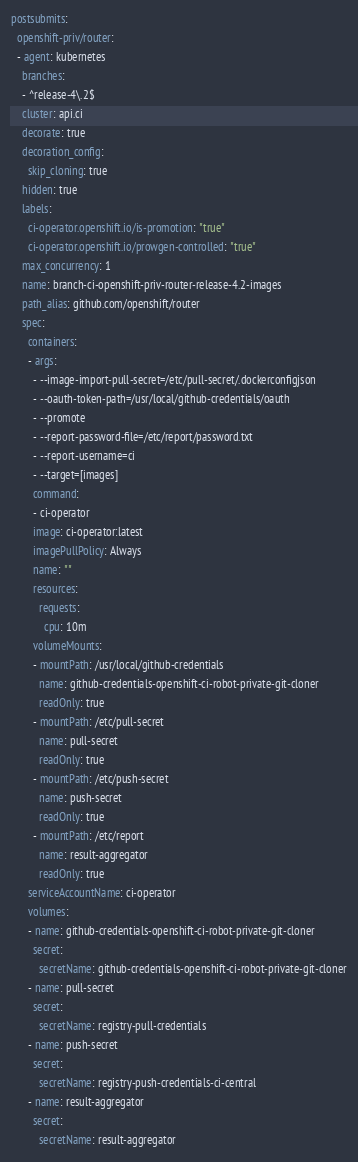<code> <loc_0><loc_0><loc_500><loc_500><_YAML_>postsubmits:
  openshift-priv/router:
  - agent: kubernetes
    branches:
    - ^release-4\.2$
    cluster: api.ci
    decorate: true
    decoration_config:
      skip_cloning: true
    hidden: true
    labels:
      ci-operator.openshift.io/is-promotion: "true"
      ci-operator.openshift.io/prowgen-controlled: "true"
    max_concurrency: 1
    name: branch-ci-openshift-priv-router-release-4.2-images
    path_alias: github.com/openshift/router
    spec:
      containers:
      - args:
        - --image-import-pull-secret=/etc/pull-secret/.dockerconfigjson
        - --oauth-token-path=/usr/local/github-credentials/oauth
        - --promote
        - --report-password-file=/etc/report/password.txt
        - --report-username=ci
        - --target=[images]
        command:
        - ci-operator
        image: ci-operator:latest
        imagePullPolicy: Always
        name: ""
        resources:
          requests:
            cpu: 10m
        volumeMounts:
        - mountPath: /usr/local/github-credentials
          name: github-credentials-openshift-ci-robot-private-git-cloner
          readOnly: true
        - mountPath: /etc/pull-secret
          name: pull-secret
          readOnly: true
        - mountPath: /etc/push-secret
          name: push-secret
          readOnly: true
        - mountPath: /etc/report
          name: result-aggregator
          readOnly: true
      serviceAccountName: ci-operator
      volumes:
      - name: github-credentials-openshift-ci-robot-private-git-cloner
        secret:
          secretName: github-credentials-openshift-ci-robot-private-git-cloner
      - name: pull-secret
        secret:
          secretName: registry-pull-credentials
      - name: push-secret
        secret:
          secretName: registry-push-credentials-ci-central
      - name: result-aggregator
        secret:
          secretName: result-aggregator
</code> 